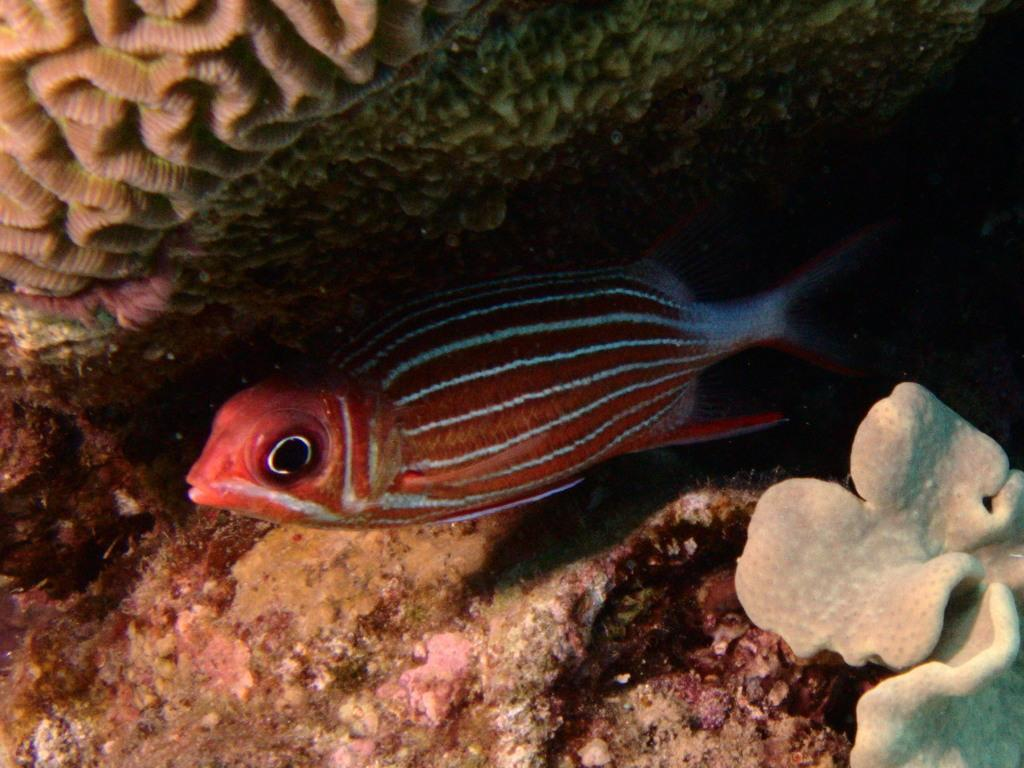What type of animal can be seen in the water in the image? There is a fish in the water in the image. Can you describe any other elements in the image besides the fish? Unfortunately, the provided facts do not specify any other elements in the image. What type of insurance policy is the fish holding in the image? There is no insurance policy or any indication of insurance in the image; it features a fish in the water. Can you tell me the color of the rose near the fish in the image? There is no rose present in the image; it only features a fish in the water. 